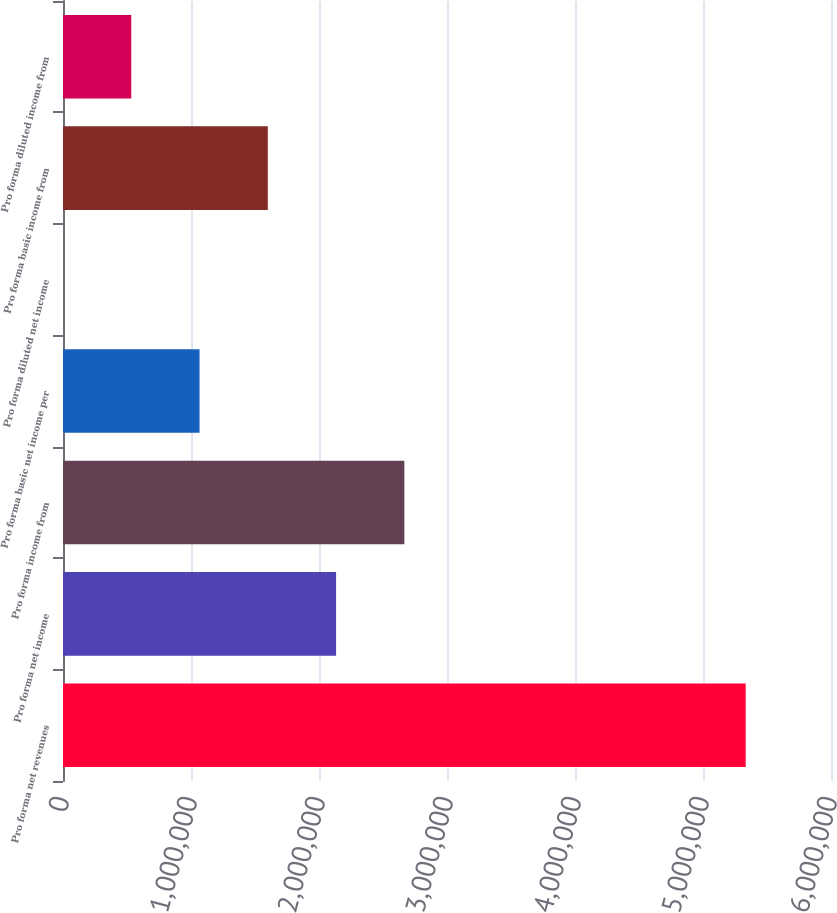Convert chart. <chart><loc_0><loc_0><loc_500><loc_500><bar_chart><fcel>Pro forma net revenues<fcel>Pro forma net income<fcel>Pro forma income from<fcel>Pro forma basic net income per<fcel>Pro forma diluted net income<fcel>Pro forma basic income from<fcel>Pro forma diluted income from<nl><fcel>5.33359e+06<fcel>2.13344e+06<fcel>2.6668e+06<fcel>1.06672e+06<fcel>3.65<fcel>1.60008e+06<fcel>533362<nl></chart> 